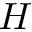Convert formula to latex. <formula><loc_0><loc_0><loc_500><loc_500>H</formula> 